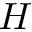Convert formula to latex. <formula><loc_0><loc_0><loc_500><loc_500>H</formula> 